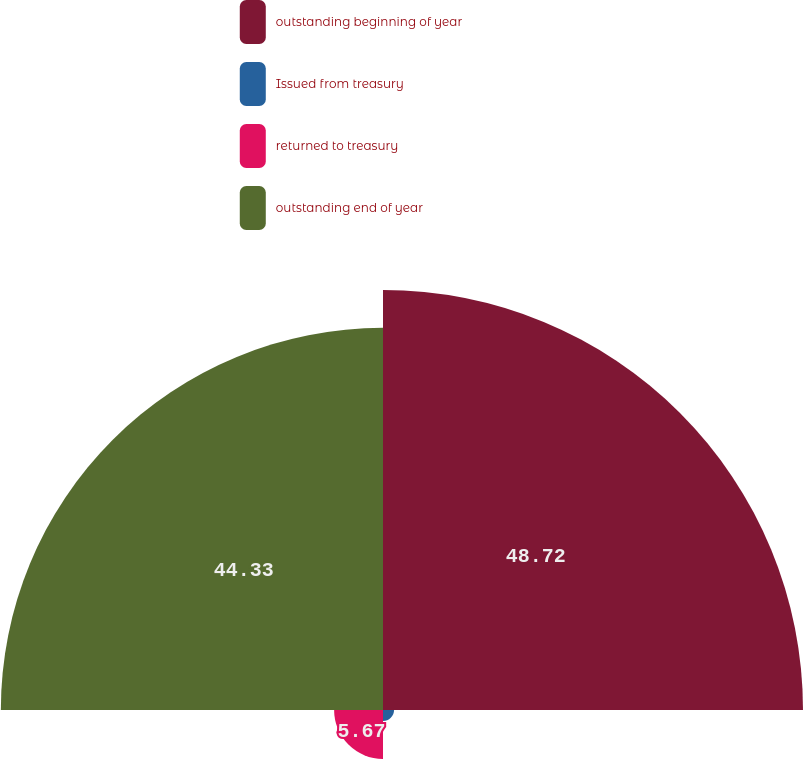Convert chart. <chart><loc_0><loc_0><loc_500><loc_500><pie_chart><fcel>outstanding beginning of year<fcel>Issued from treasury<fcel>returned to treasury<fcel>outstanding end of year<nl><fcel>48.72%<fcel>1.28%<fcel>5.67%<fcel>44.33%<nl></chart> 